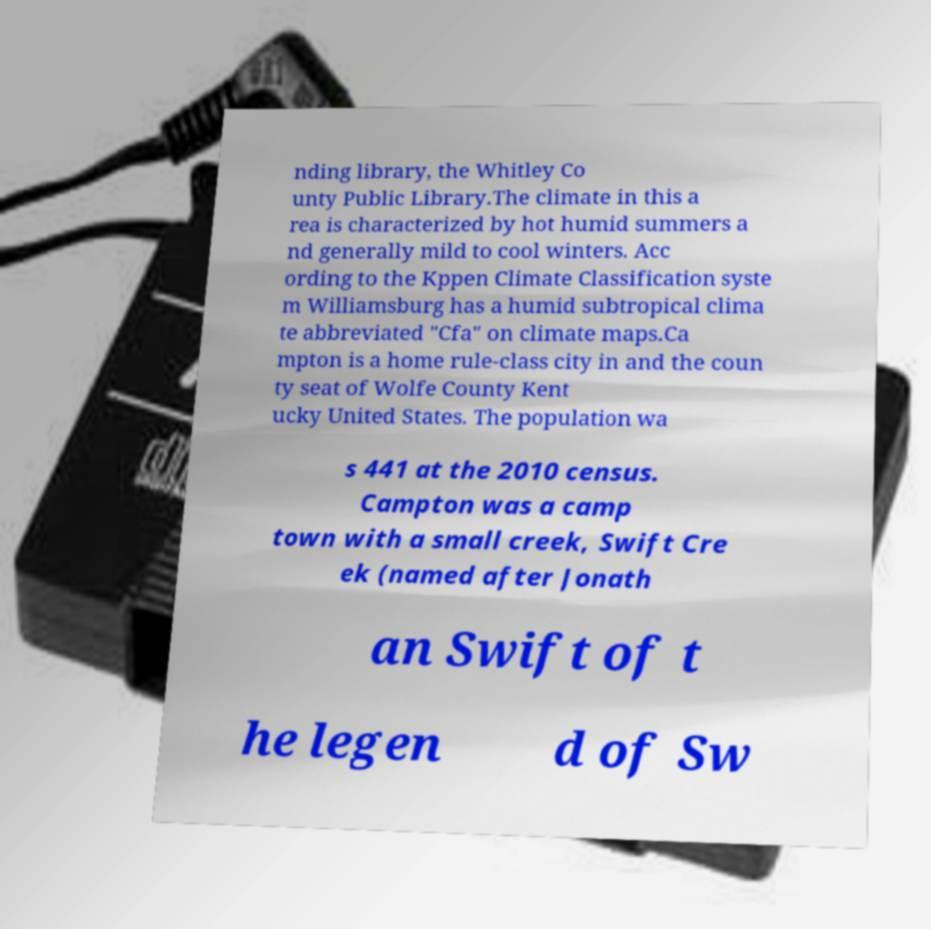Could you extract and type out the text from this image? nding library, the Whitley Co unty Public Library.The climate in this a rea is characterized by hot humid summers a nd generally mild to cool winters. Acc ording to the Kppen Climate Classification syste m Williamsburg has a humid subtropical clima te abbreviated "Cfa" on climate maps.Ca mpton is a home rule-class city in and the coun ty seat of Wolfe County Kent ucky United States. The population wa s 441 at the 2010 census. Campton was a camp town with a small creek, Swift Cre ek (named after Jonath an Swift of t he legen d of Sw 